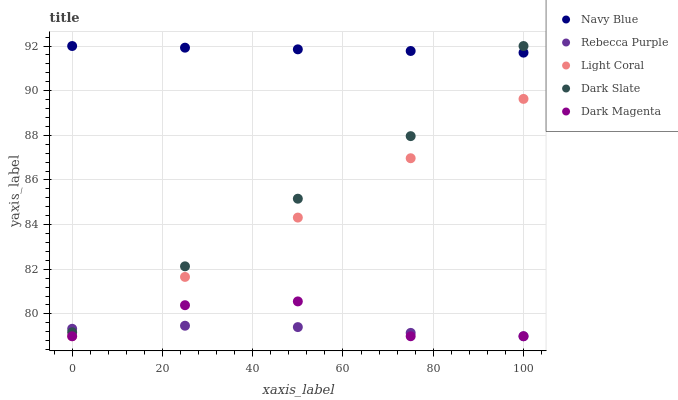Does Rebecca Purple have the minimum area under the curve?
Answer yes or no. Yes. Does Navy Blue have the maximum area under the curve?
Answer yes or no. Yes. Does Navy Blue have the minimum area under the curve?
Answer yes or no. No. Does Rebecca Purple have the maximum area under the curve?
Answer yes or no. No. Is Light Coral the smoothest?
Answer yes or no. Yes. Is Dark Magenta the roughest?
Answer yes or no. Yes. Is Navy Blue the smoothest?
Answer yes or no. No. Is Navy Blue the roughest?
Answer yes or no. No. Does Light Coral have the lowest value?
Answer yes or no. Yes. Does Navy Blue have the lowest value?
Answer yes or no. No. Does Dark Slate have the highest value?
Answer yes or no. Yes. Does Rebecca Purple have the highest value?
Answer yes or no. No. Is Dark Magenta less than Dark Slate?
Answer yes or no. Yes. Is Navy Blue greater than Rebecca Purple?
Answer yes or no. Yes. Does Light Coral intersect Dark Magenta?
Answer yes or no. Yes. Is Light Coral less than Dark Magenta?
Answer yes or no. No. Is Light Coral greater than Dark Magenta?
Answer yes or no. No. Does Dark Magenta intersect Dark Slate?
Answer yes or no. No. 